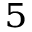<formula> <loc_0><loc_0><loc_500><loc_500>^ { 5 }</formula> 